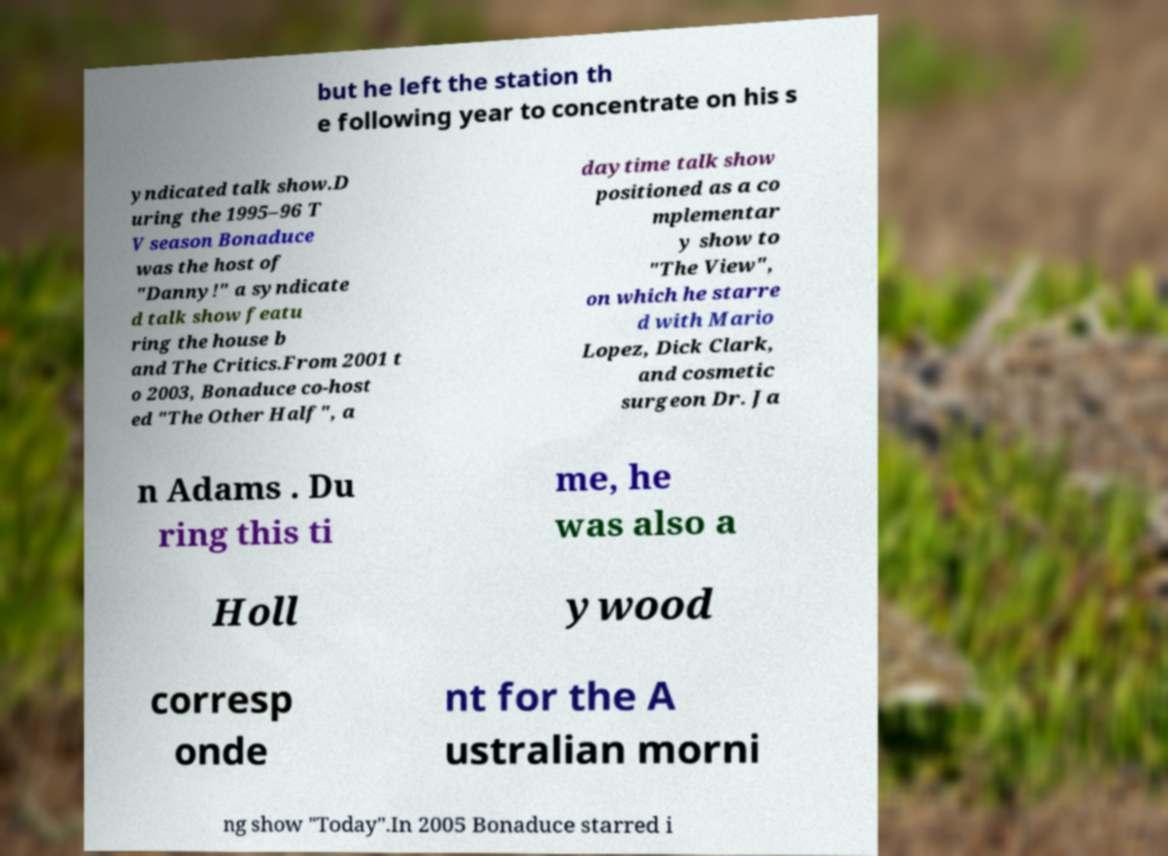What messages or text are displayed in this image? I need them in a readable, typed format. but he left the station th e following year to concentrate on his s yndicated talk show.D uring the 1995–96 T V season Bonaduce was the host of "Danny!" a syndicate d talk show featu ring the house b and The Critics.From 2001 t o 2003, Bonaduce co-host ed "The Other Half", a daytime talk show positioned as a co mplementar y show to "The View", on which he starre d with Mario Lopez, Dick Clark, and cosmetic surgeon Dr. Ja n Adams . Du ring this ti me, he was also a Holl ywood corresp onde nt for the A ustralian morni ng show "Today".In 2005 Bonaduce starred i 